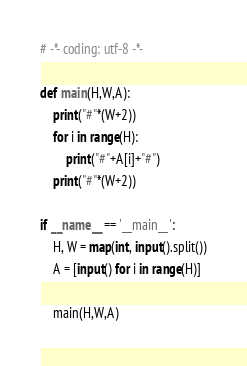Convert code to text. <code><loc_0><loc_0><loc_500><loc_500><_Python_># -*- coding: utf-8 -*-

def main(H,W,A):
    print("#"*(W+2))
    for i in range(H):
        print("#"+A[i]+"#")
    print("#"*(W+2))
    
if __name__ == '__main__':
    H, W = map(int, input().split())
    A = [input() for i in range(H)]
    
    main(H,W,A)</code> 